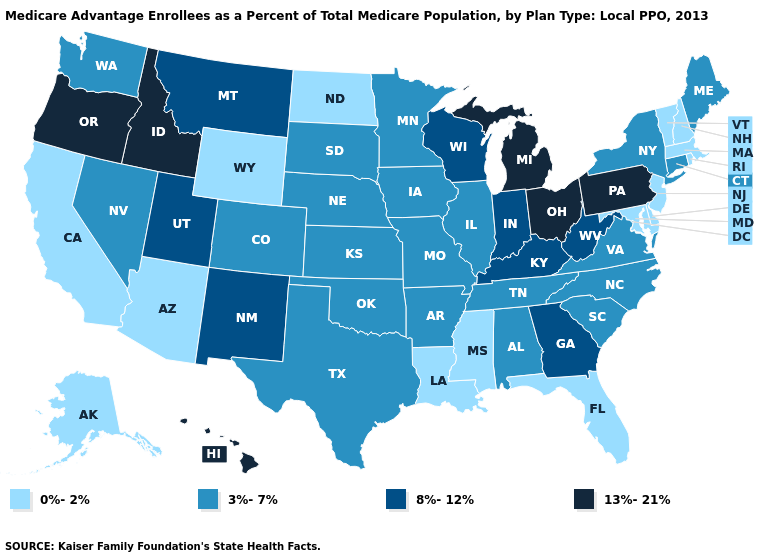Does Utah have a lower value than New York?
Be succinct. No. Among the states that border Ohio , does West Virginia have the lowest value?
Short answer required. Yes. Name the states that have a value in the range 13%-21%?
Answer briefly. Hawaii, Idaho, Michigan, Ohio, Oregon, Pennsylvania. Name the states that have a value in the range 13%-21%?
Short answer required. Hawaii, Idaho, Michigan, Ohio, Oregon, Pennsylvania. Name the states that have a value in the range 8%-12%?
Give a very brief answer. Georgia, Indiana, Kentucky, Montana, New Mexico, Utah, Wisconsin, West Virginia. What is the lowest value in the South?
Concise answer only. 0%-2%. Does New York have the same value as Minnesota?
Answer briefly. Yes. Does Ohio have the highest value in the MidWest?
Concise answer only. Yes. Name the states that have a value in the range 13%-21%?
Give a very brief answer. Hawaii, Idaho, Michigan, Ohio, Oregon, Pennsylvania. Does Delaware have the highest value in the USA?
Keep it brief. No. Name the states that have a value in the range 0%-2%?
Concise answer only. Alaska, Arizona, California, Delaware, Florida, Louisiana, Massachusetts, Maryland, Mississippi, North Dakota, New Hampshire, New Jersey, Rhode Island, Vermont, Wyoming. What is the highest value in the USA?
Write a very short answer. 13%-21%. Does Kentucky have the same value as West Virginia?
Quick response, please. Yes. Among the states that border Ohio , does Pennsylvania have the highest value?
Quick response, please. Yes. What is the value of California?
Keep it brief. 0%-2%. 